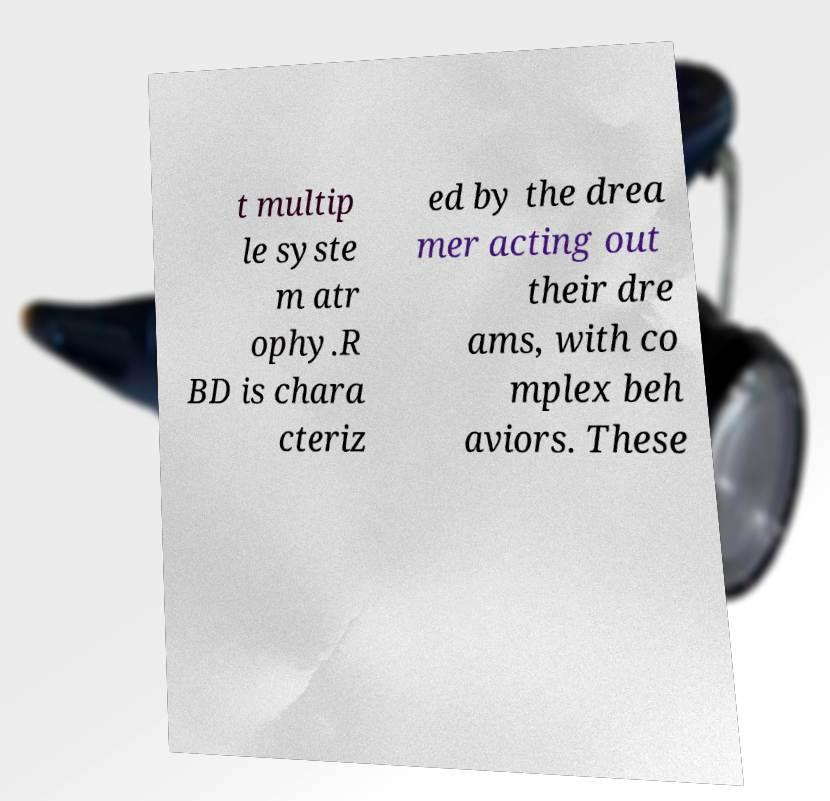What messages or text are displayed in this image? I need them in a readable, typed format. t multip le syste m atr ophy.R BD is chara cteriz ed by the drea mer acting out their dre ams, with co mplex beh aviors. These 